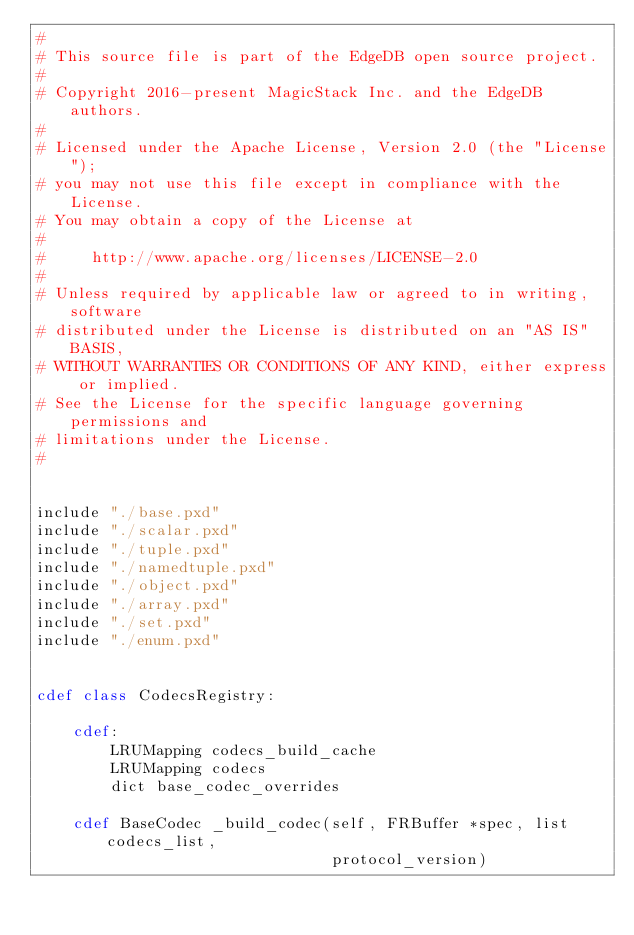<code> <loc_0><loc_0><loc_500><loc_500><_Cython_>#
# This source file is part of the EdgeDB open source project.
#
# Copyright 2016-present MagicStack Inc. and the EdgeDB authors.
#
# Licensed under the Apache License, Version 2.0 (the "License");
# you may not use this file except in compliance with the License.
# You may obtain a copy of the License at
#
#     http://www.apache.org/licenses/LICENSE-2.0
#
# Unless required by applicable law or agreed to in writing, software
# distributed under the License is distributed on an "AS IS" BASIS,
# WITHOUT WARRANTIES OR CONDITIONS OF ANY KIND, either express or implied.
# See the License for the specific language governing permissions and
# limitations under the License.
#


include "./base.pxd"
include "./scalar.pxd"
include "./tuple.pxd"
include "./namedtuple.pxd"
include "./object.pxd"
include "./array.pxd"
include "./set.pxd"
include "./enum.pxd"


cdef class CodecsRegistry:

    cdef:
        LRUMapping codecs_build_cache
        LRUMapping codecs
        dict base_codec_overrides

    cdef BaseCodec _build_codec(self, FRBuffer *spec, list codecs_list,
                                protocol_version)</code> 